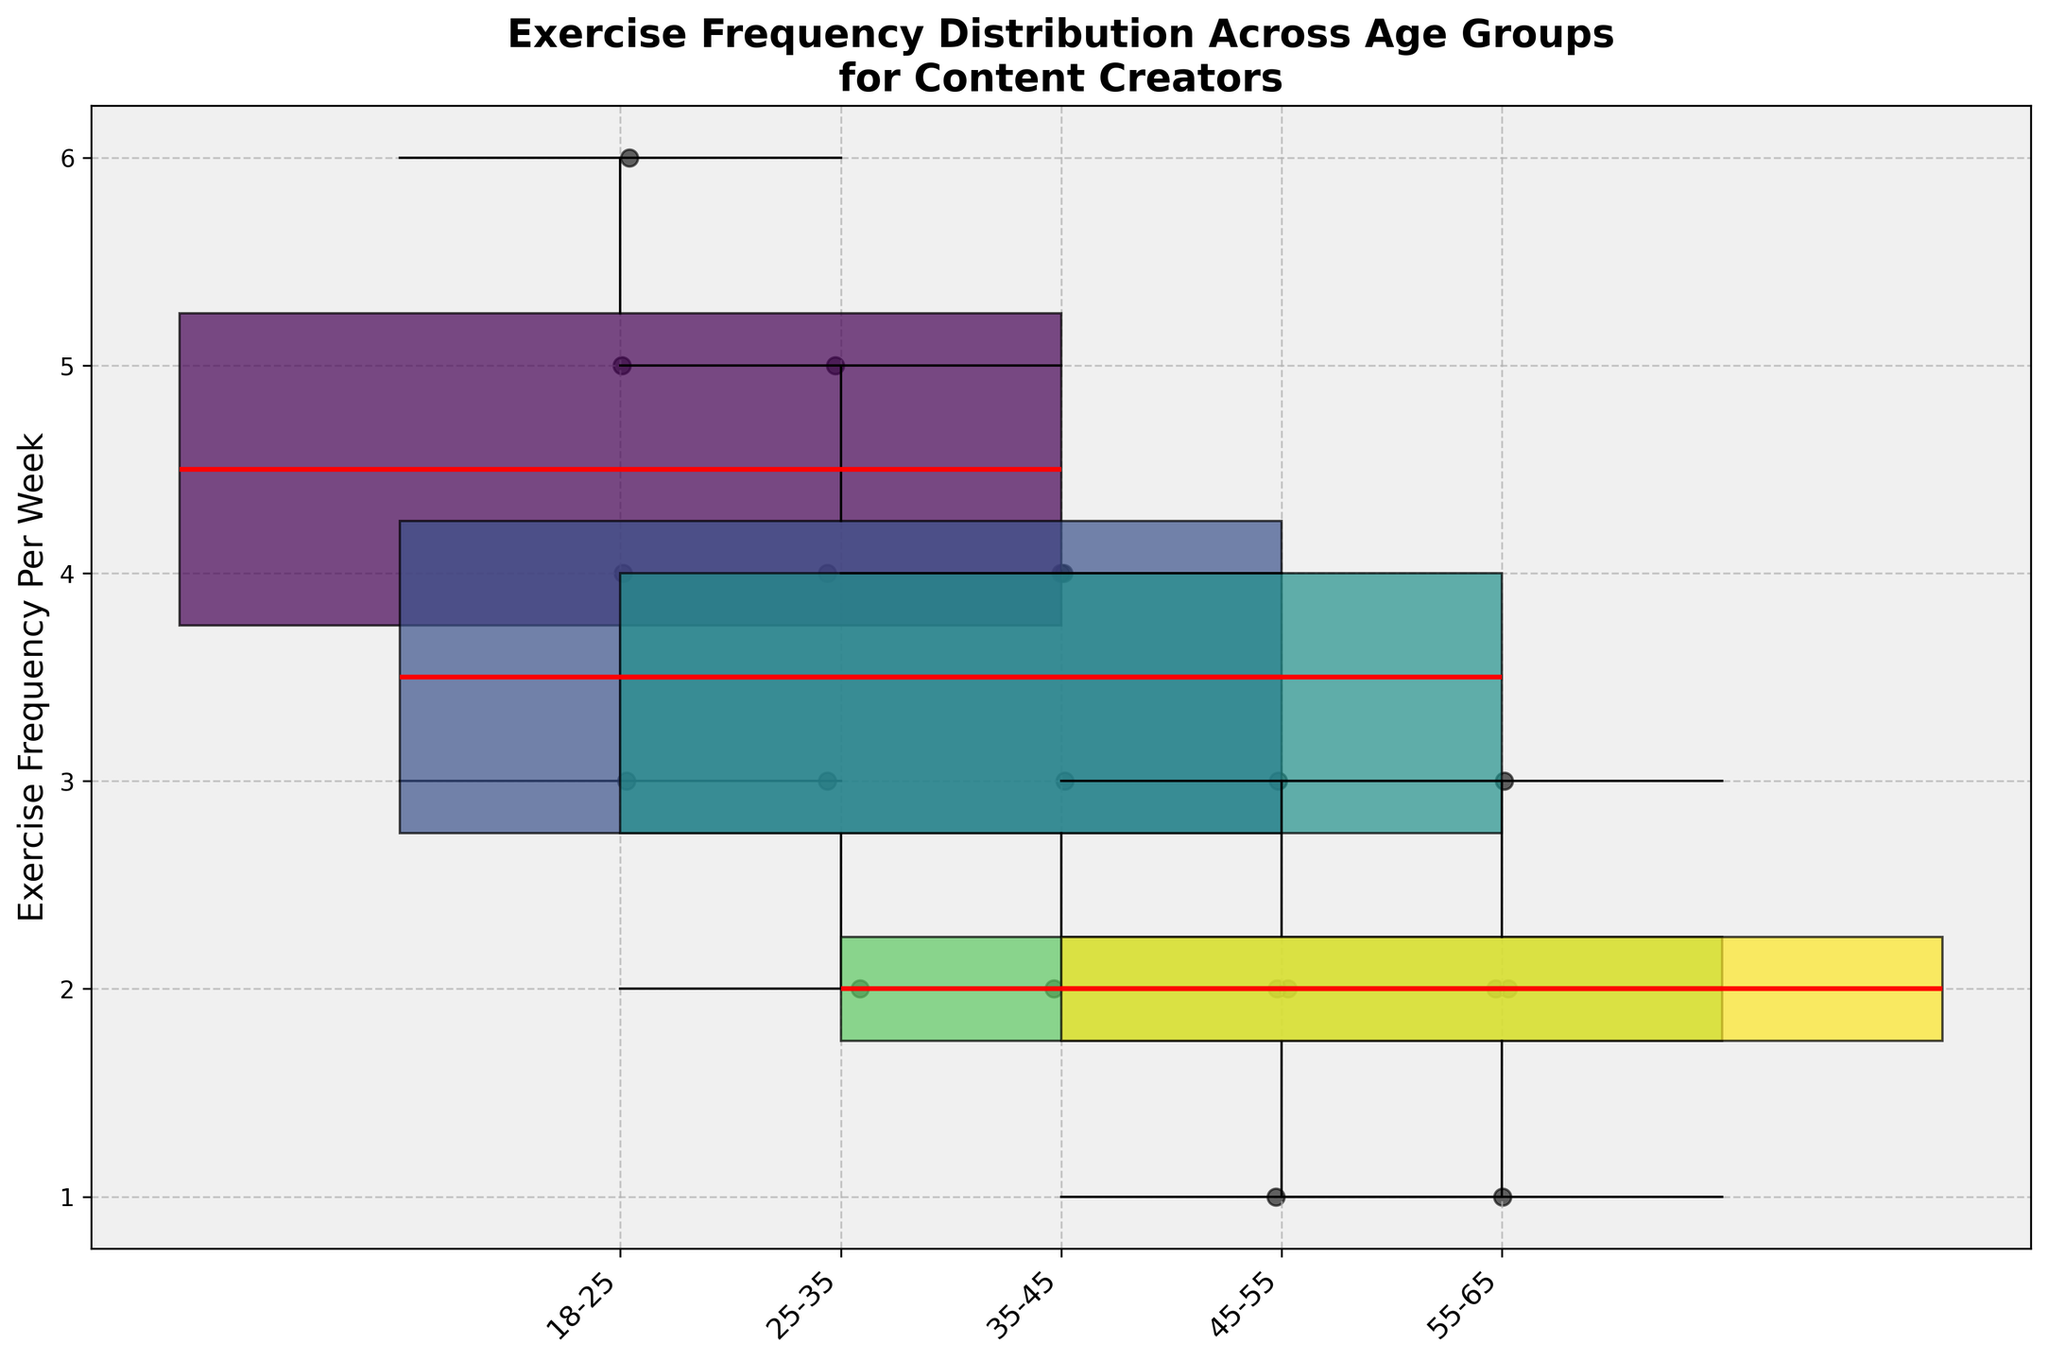What's the title of the plot? The title is displayed at the top of the plot, providing an overview of what the figure represents.
Answer: Exercise Frequency Distribution Across Age Groups for Content Creators Which age group has the widest box plot? The width of each box plot is proportional to the number of data points in that group. The group with the most data points will have the widest box.
Answer: 18-25 What is the median exercise frequency for the 55-65 age group? The median is the middle line within the box plot. For the 55-65 age group, locate the red line inside the box.
Answer: 2 Which age group has the highest maximum exercise frequency? The maximum is the top whisker of each box plot. Look for the highest whisker among the age groups.
Answer: 18-25 What is the range of exercise frequency for the 45-55 age group? The range is the difference between the maximum and minimum values of the whiskers in the box plot. Identify the top and bottom whiskers for the 45-55 age group and subtract the minimum from the maximum.
Answer: 2 How does the exercise frequency distribution of the 25-35 age group compare to that of the 35-45 age group? Compare the position, spread, and outliers of the box plots for these age groups. Note the median lines and the range of values.
Answer: The 25-35 group has a higher median and wider range than the 35-45 group Which age group has the lowest median exercise frequency? The median is the red line inside the box. Identify the age group with the lowest positioned median line.
Answer: 55-65 Are there any outliers in the exercise frequency data? If so, in which age groups? Outliers are shown as individual points outside the whiskers of the box plots. Examine each box plot for such points.
Answer: No outliers What is the interquartile range (IQR) for the 18-25 age group? The IQR is the height of the box, representing the middle 50% of the data. It's the difference between the 3rd quartile (top of the box) and the 1st quartile (bottom of the box). Measure this height.
Answer: 2 Which age group has the most consistent exercise frequency? The most consistent group will have the smallest spread, indicated by the smallest IQR or the smallest range between whiskers.
Answer: 55-65 